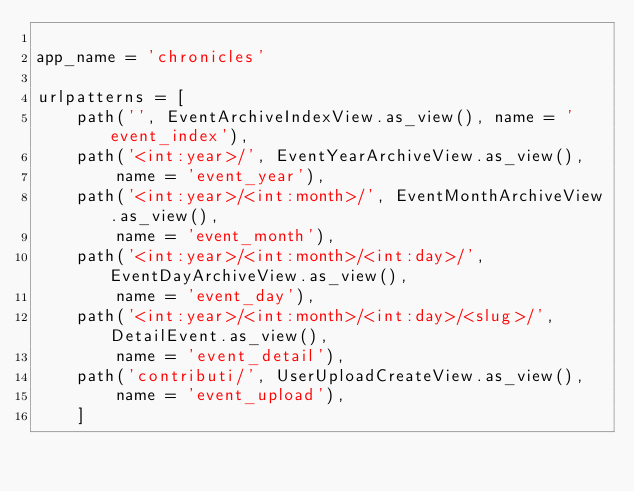<code> <loc_0><loc_0><loc_500><loc_500><_Python_>
app_name = 'chronicles'

urlpatterns = [
    path('', EventArchiveIndexView.as_view(), name = 'event_index'),
    path('<int:year>/', EventYearArchiveView.as_view(),
        name = 'event_year'),
    path('<int:year>/<int:month>/', EventMonthArchiveView.as_view(),
        name = 'event_month'),
    path('<int:year>/<int:month>/<int:day>/', EventDayArchiveView.as_view(),
        name = 'event_day'),
    path('<int:year>/<int:month>/<int:day>/<slug>/', DetailEvent.as_view(),
        name = 'event_detail'),
    path('contributi/', UserUploadCreateView.as_view(),
        name = 'event_upload'),
    ]
</code> 